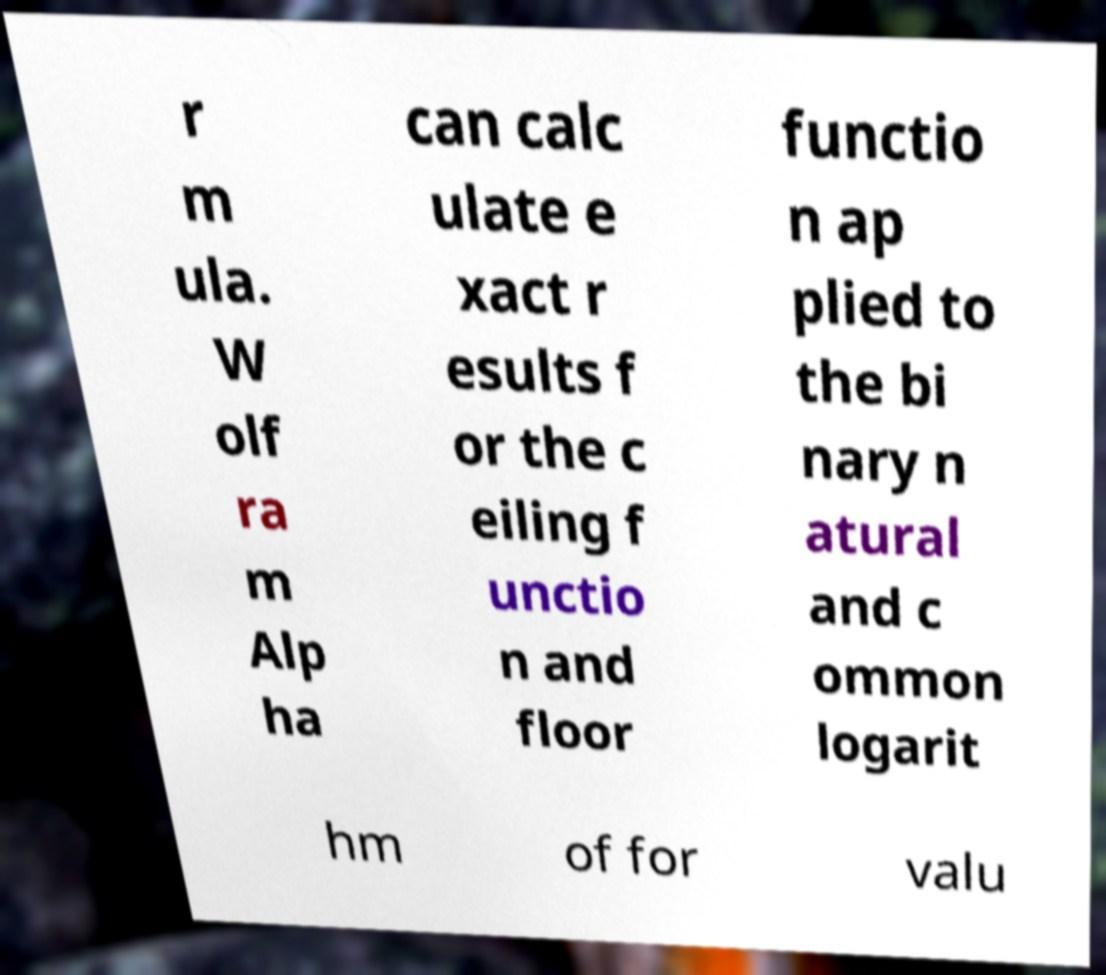What messages or text are displayed in this image? I need them in a readable, typed format. r m ula. W olf ra m Alp ha can calc ulate e xact r esults f or the c eiling f unctio n and floor functio n ap plied to the bi nary n atural and c ommon logarit hm of for valu 